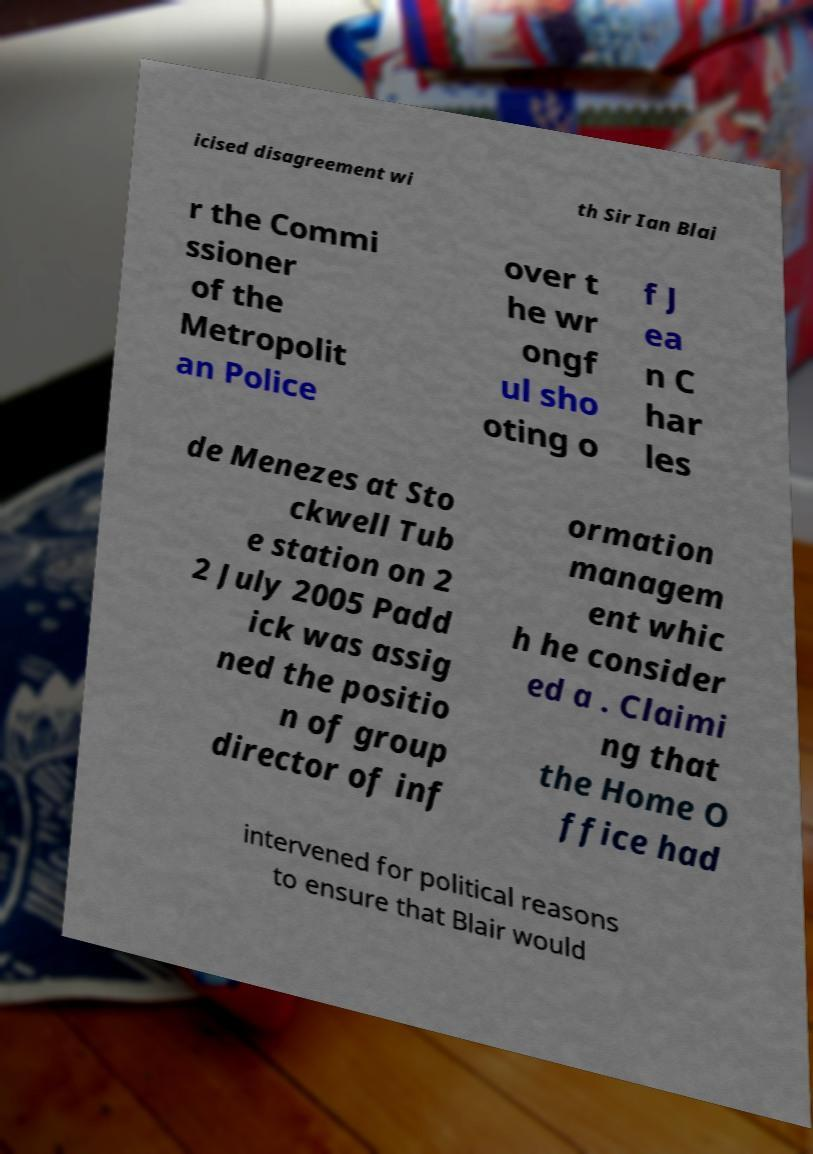Can you accurately transcribe the text from the provided image for me? icised disagreement wi th Sir Ian Blai r the Commi ssioner of the Metropolit an Police over t he wr ongf ul sho oting o f J ea n C har les de Menezes at Sto ckwell Tub e station on 2 2 July 2005 Padd ick was assig ned the positio n of group director of inf ormation managem ent whic h he consider ed a . Claimi ng that the Home O ffice had intervened for political reasons to ensure that Blair would 